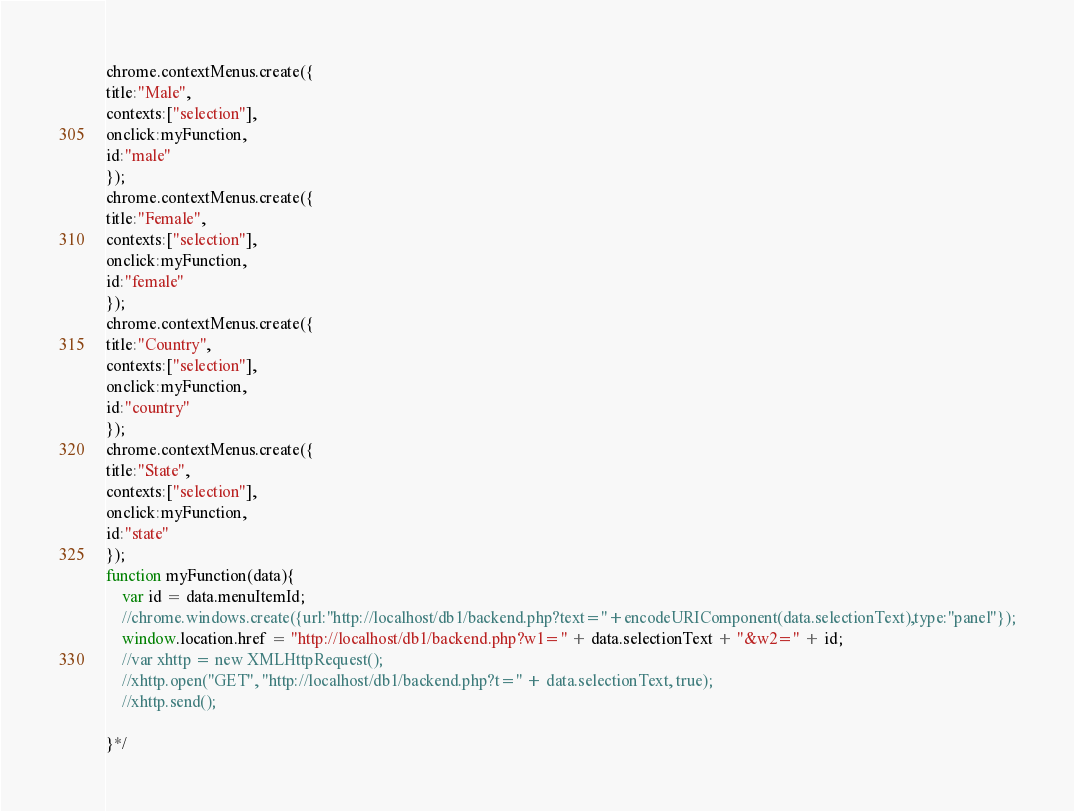Convert code to text. <code><loc_0><loc_0><loc_500><loc_500><_JavaScript_>chrome.contextMenus.create({
title:"Male",
contexts:["selection"],
onclick:myFunction,
id:"male"
});
chrome.contextMenus.create({
title:"Female",
contexts:["selection"],
onclick:myFunction,
id:"female"
});
chrome.contextMenus.create({
title:"Country",
contexts:["selection"],
onclick:myFunction,
id:"country"
});
chrome.contextMenus.create({
title:"State",
contexts:["selection"],
onclick:myFunction,
id:"state"
});
function myFunction(data){
	var id = data.menuItemId;
	//chrome.windows.create({url:"http://localhost/db1/backend.php?text="+encodeURIComponent(data.selectionText),type:"panel"});
	window.location.href = "http://localhost/db1/backend.php?w1=" + data.selectionText + "&w2=" + id;
	//var xhttp = new XMLHttpRequest();
	//xhttp.open("GET", "http://localhost/db1/backend.php?t=" + data.selectionText, true);
	//xhttp.send();

}*/

</code> 